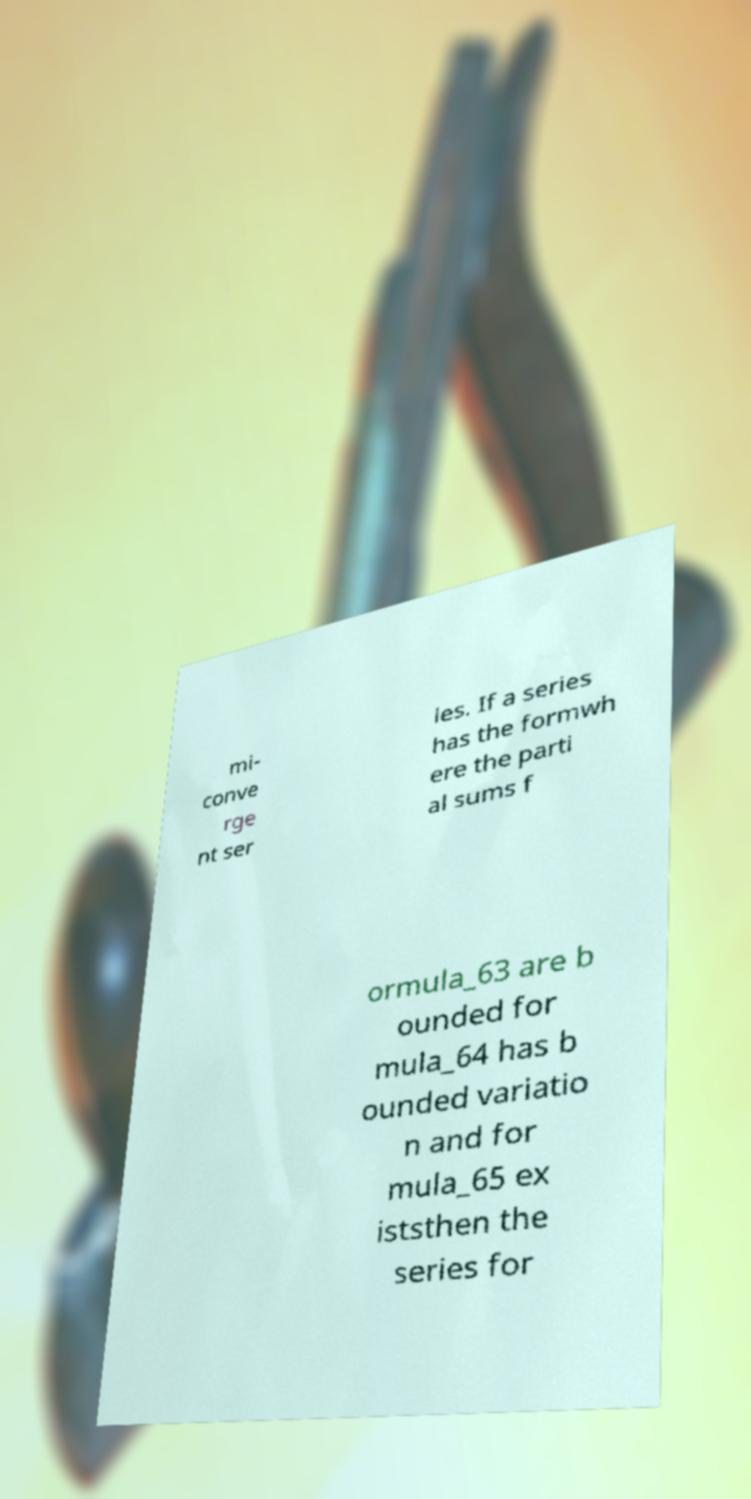Can you read and provide the text displayed in the image?This photo seems to have some interesting text. Can you extract and type it out for me? mi- conve rge nt ser ies. If a series has the formwh ere the parti al sums f ormula_63 are b ounded for mula_64 has b ounded variatio n and for mula_65 ex iststhen the series for 